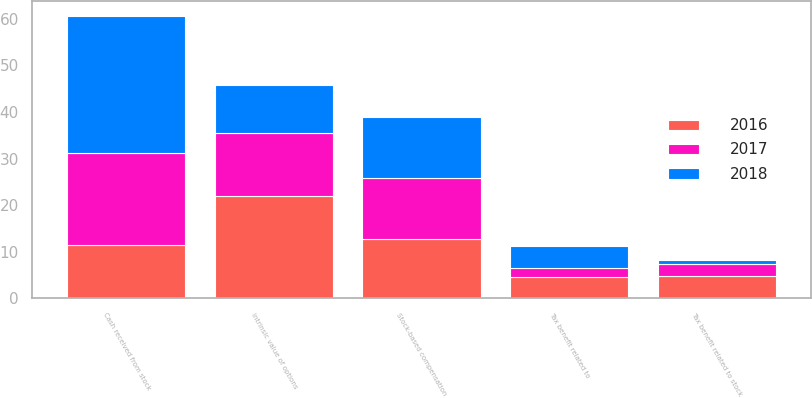<chart> <loc_0><loc_0><loc_500><loc_500><stacked_bar_chart><ecel><fcel>Intrinsic value of options<fcel>Cash received from stock<fcel>Tax benefit related to stock<fcel>Stock-based compensation<fcel>Tax benefit related to<nl><fcel>2017<fcel>13.4<fcel>19.7<fcel>2.4<fcel>13.2<fcel>1.9<nl><fcel>2016<fcel>22<fcel>11.55<fcel>4.9<fcel>12.7<fcel>4.6<nl><fcel>2018<fcel>10.4<fcel>29.4<fcel>1<fcel>13.1<fcel>4.7<nl></chart> 